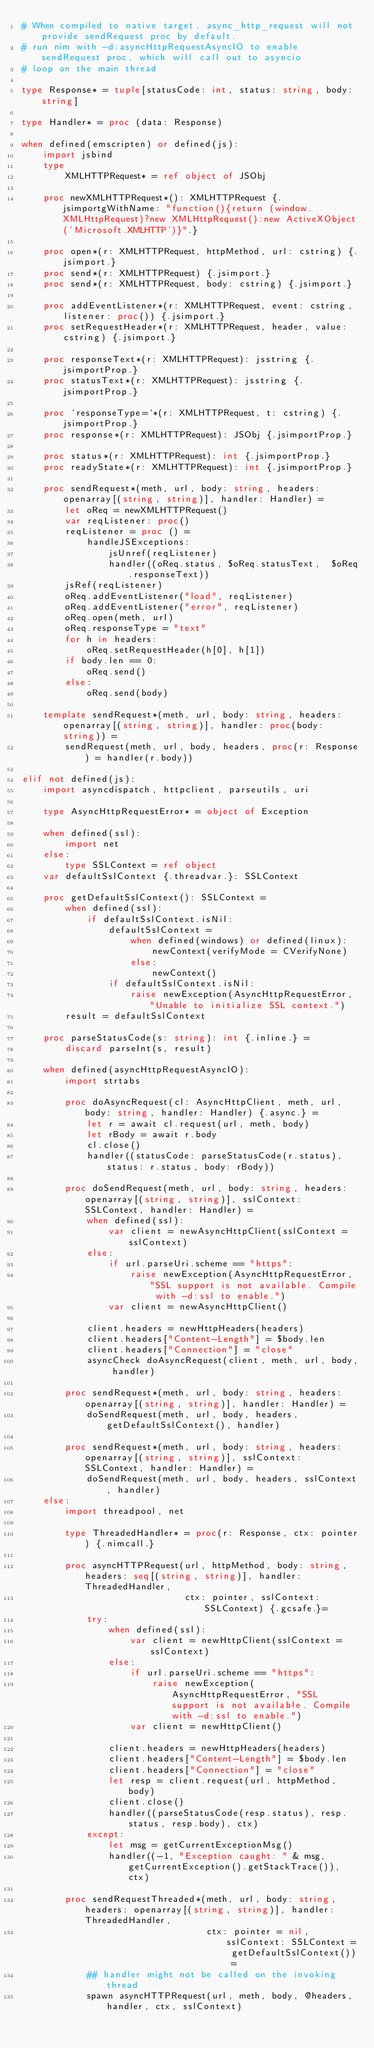<code> <loc_0><loc_0><loc_500><loc_500><_Nim_># When compiled to native target, async_http_request will not provide sendRequest proc by default.
# run nim with -d:asyncHttpRequestAsyncIO to enable sendRequest proc, which will call out to asyncio
# loop on the main thread

type Response* = tuple[statusCode: int, status: string, body: string]

type Handler* = proc (data: Response)

when defined(emscripten) or defined(js):
    import jsbind
    type
        XMLHTTPRequest* = ref object of JSObj

    proc newXMLHTTPRequest*(): XMLHTTPRequest {.jsimportgWithName: "function(){return (window.XMLHttpRequest)?new XMLHttpRequest():new ActiveXObject('Microsoft.XMLHTTP')}".}

    proc open*(r: XMLHTTPRequest, httpMethod, url: cstring) {.jsimport.}
    proc send*(r: XMLHTTPRequest) {.jsimport.}
    proc send*(r: XMLHTTPRequest, body: cstring) {.jsimport.}

    proc addEventListener*(r: XMLHTTPRequest, event: cstring, listener: proc()) {.jsimport.}
    proc setRequestHeader*(r: XMLHTTPRequest, header, value: cstring) {.jsimport.}

    proc responseText*(r: XMLHTTPRequest): jsstring {.jsimportProp.}
    proc statusText*(r: XMLHTTPRequest): jsstring {.jsimportProp.}

    proc `responseType=`*(r: XMLHTTPRequest, t: cstring) {.jsimportProp.}
    proc response*(r: XMLHTTPRequest): JSObj {.jsimportProp.}

    proc status*(r: XMLHTTPRequest): int {.jsimportProp.}
    proc readyState*(r: XMLHTTPRequest): int {.jsimportProp.}

    proc sendRequest*(meth, url, body: string, headers: openarray[(string, string)], handler: Handler) =
        let oReq = newXMLHTTPRequest()
        var reqListener: proc()
        reqListener = proc () =
            handleJSExceptions:
                jsUnref(reqListener)
                handler((oReq.status, $oReq.statusText,  $oReq.responseText))
        jsRef(reqListener)
        oReq.addEventListener("load", reqListener)
        oReq.addEventListener("error", reqListener)
        oReq.open(meth, url)
        oReq.responseType = "text"
        for h in headers:
            oReq.setRequestHeader(h[0], h[1])
        if body.len == 0:
            oReq.send()
        else:
            oReq.send(body)

    template sendRequest*(meth, url, body: string, headers: openarray[(string, string)], handler: proc(body: string)) =
        sendRequest(meth, url, body, headers, proc(r: Response) = handler(r.body))

elif not defined(js):
    import asyncdispatch, httpclient, parseutils, uri

    type AsyncHttpRequestError* = object of Exception

    when defined(ssl):
        import net
    else:
        type SSLContext = ref object
    var defaultSslContext {.threadvar.}: SSLContext

    proc getDefaultSslContext(): SSLContext =
        when defined(ssl):
            if defaultSslContext.isNil:
                defaultSslContext =
                    when defined(windows) or defined(linux):
                        newContext(verifyMode = CVerifyNone)
                    else:
                        newContext()
                if defaultSslContext.isNil:
                    raise newException(AsyncHttpRequestError, "Unable to initialize SSL context.")
        result = defaultSslContext

    proc parseStatusCode(s: string): int {.inline.} =
        discard parseInt(s, result)

    when defined(asyncHttpRequestAsyncIO):
        import strtabs

        proc doAsyncRequest(cl: AsyncHttpClient, meth, url, body: string, handler: Handler) {.async.} =
            let r = await cl.request(url, meth, body)
            let rBody = await r.body
            cl.close()
            handler((statusCode: parseStatusCode(r.status), status: r.status, body: rBody))

        proc doSendRequest(meth, url, body: string, headers: openarray[(string, string)], sslContext: SSLContext, handler: Handler) =
            when defined(ssl):
                var client = newAsyncHttpClient(sslContext = sslContext)
            else:
                if url.parseUri.scheme == "https":
                    raise newException(AsyncHttpRequestError, "SSL support is not available. Compile with -d:ssl to enable.")
                var client = newAsyncHttpClient()

            client.headers = newHttpHeaders(headers)
            client.headers["Content-Length"] = $body.len
            client.headers["Connection"] = "close"
            asyncCheck doAsyncRequest(client, meth, url, body, handler)

        proc sendRequest*(meth, url, body: string, headers: openarray[(string, string)], handler: Handler) =
            doSendRequest(meth, url, body, headers, getDefaultSslContext(), handler)

        proc sendRequest*(meth, url, body: string, headers: openarray[(string, string)], sslContext: SSLContext, handler: Handler) =
            doSendRequest(meth, url, body, headers, sslContext, handler)
    else:
        import threadpool, net

        type ThreadedHandler* = proc(r: Response, ctx: pointer) {.nimcall.}

        proc asyncHTTPRequest(url, httpMethod, body: string, headers: seq[(string, string)], handler: ThreadedHandler,
                              ctx: pointer, sslContext: SSLContext) {.gcsafe.}=
            try:
                when defined(ssl):
                    var client = newHttpClient(sslContext = sslContext)
                else:
                    if url.parseUri.scheme == "https":
                        raise newException(AsyncHttpRequestError, "SSL support is not available. Compile with -d:ssl to enable.")
                    var client = newHttpClient()

                client.headers = newHttpHeaders(headers)
                client.headers["Content-Length"] = $body.len
                client.headers["Connection"] = "close"
                let resp = client.request(url, httpMethod, body)
                client.close()
                handler((parseStatusCode(resp.status), resp.status, resp.body), ctx)
            except:
                let msg = getCurrentExceptionMsg()
                handler((-1, "Exception caught: " & msg, getCurrentException().getStackTrace()), ctx)

        proc sendRequestThreaded*(meth, url, body: string, headers: openarray[(string, string)], handler: ThreadedHandler,
                                  ctx: pointer = nil, sslContext: SSLContext = getDefaultSslContext()) =
            ## handler might not be called on the invoking thread
            spawn asyncHTTPRequest(url, meth, body, @headers, handler, ctx, sslContext)
</code> 